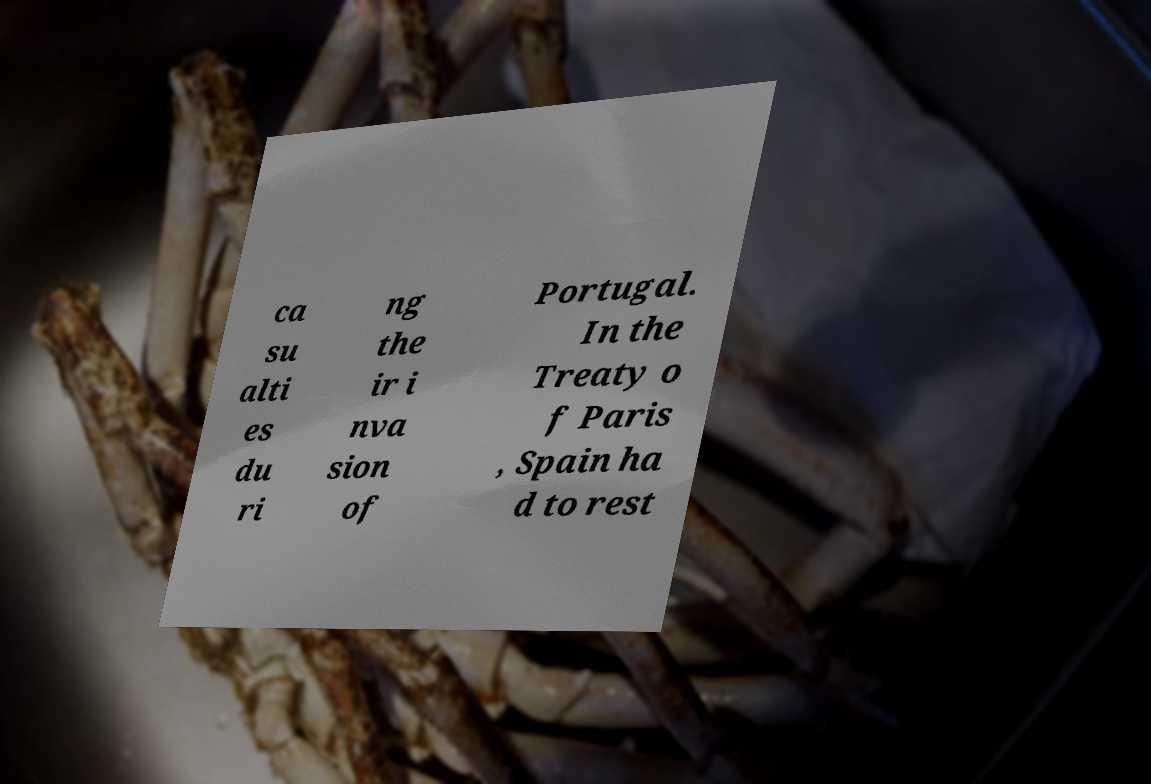I need the written content from this picture converted into text. Can you do that? ca su alti es du ri ng the ir i nva sion of Portugal. In the Treaty o f Paris , Spain ha d to rest 